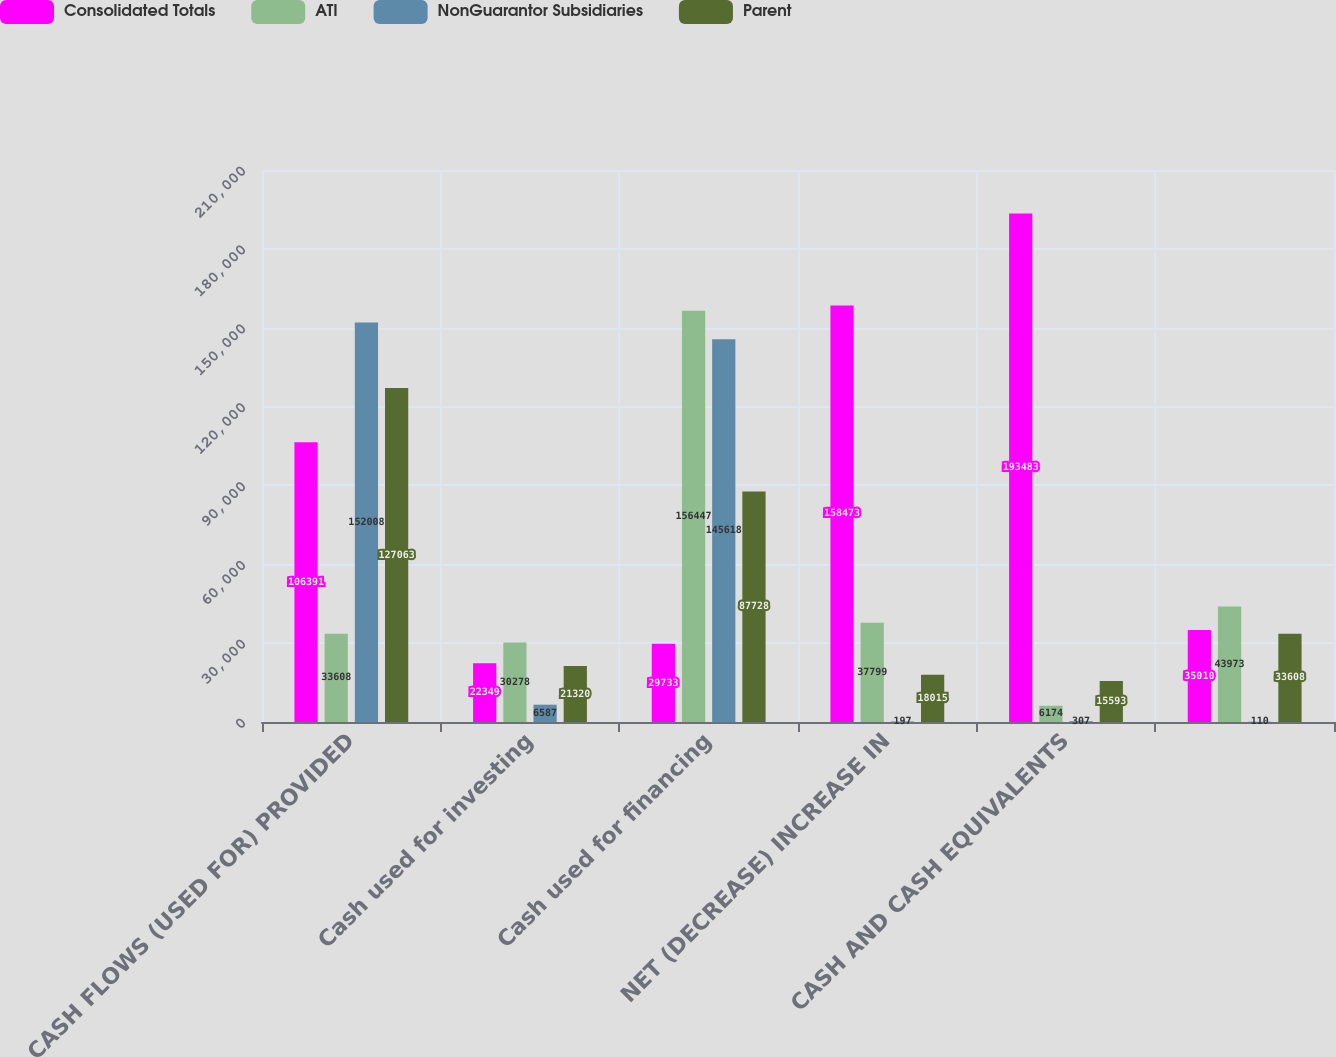<chart> <loc_0><loc_0><loc_500><loc_500><stacked_bar_chart><ecel><fcel>CASH FLOWS (USED FOR) PROVIDED<fcel>Cash used for investing<fcel>Cash used for financing<fcel>NET (DECREASE) INCREASE IN<fcel>CASH AND CASH EQUIVALENTS<fcel>Unnamed: 6<nl><fcel>Consolidated Totals<fcel>106391<fcel>22349<fcel>29733<fcel>158473<fcel>193483<fcel>35010<nl><fcel>ATI<fcel>33608<fcel>30278<fcel>156447<fcel>37799<fcel>6174<fcel>43973<nl><fcel>NonGuarantor Subsidiaries<fcel>152008<fcel>6587<fcel>145618<fcel>197<fcel>307<fcel>110<nl><fcel>Parent<fcel>127063<fcel>21320<fcel>87728<fcel>18015<fcel>15593<fcel>33608<nl></chart> 